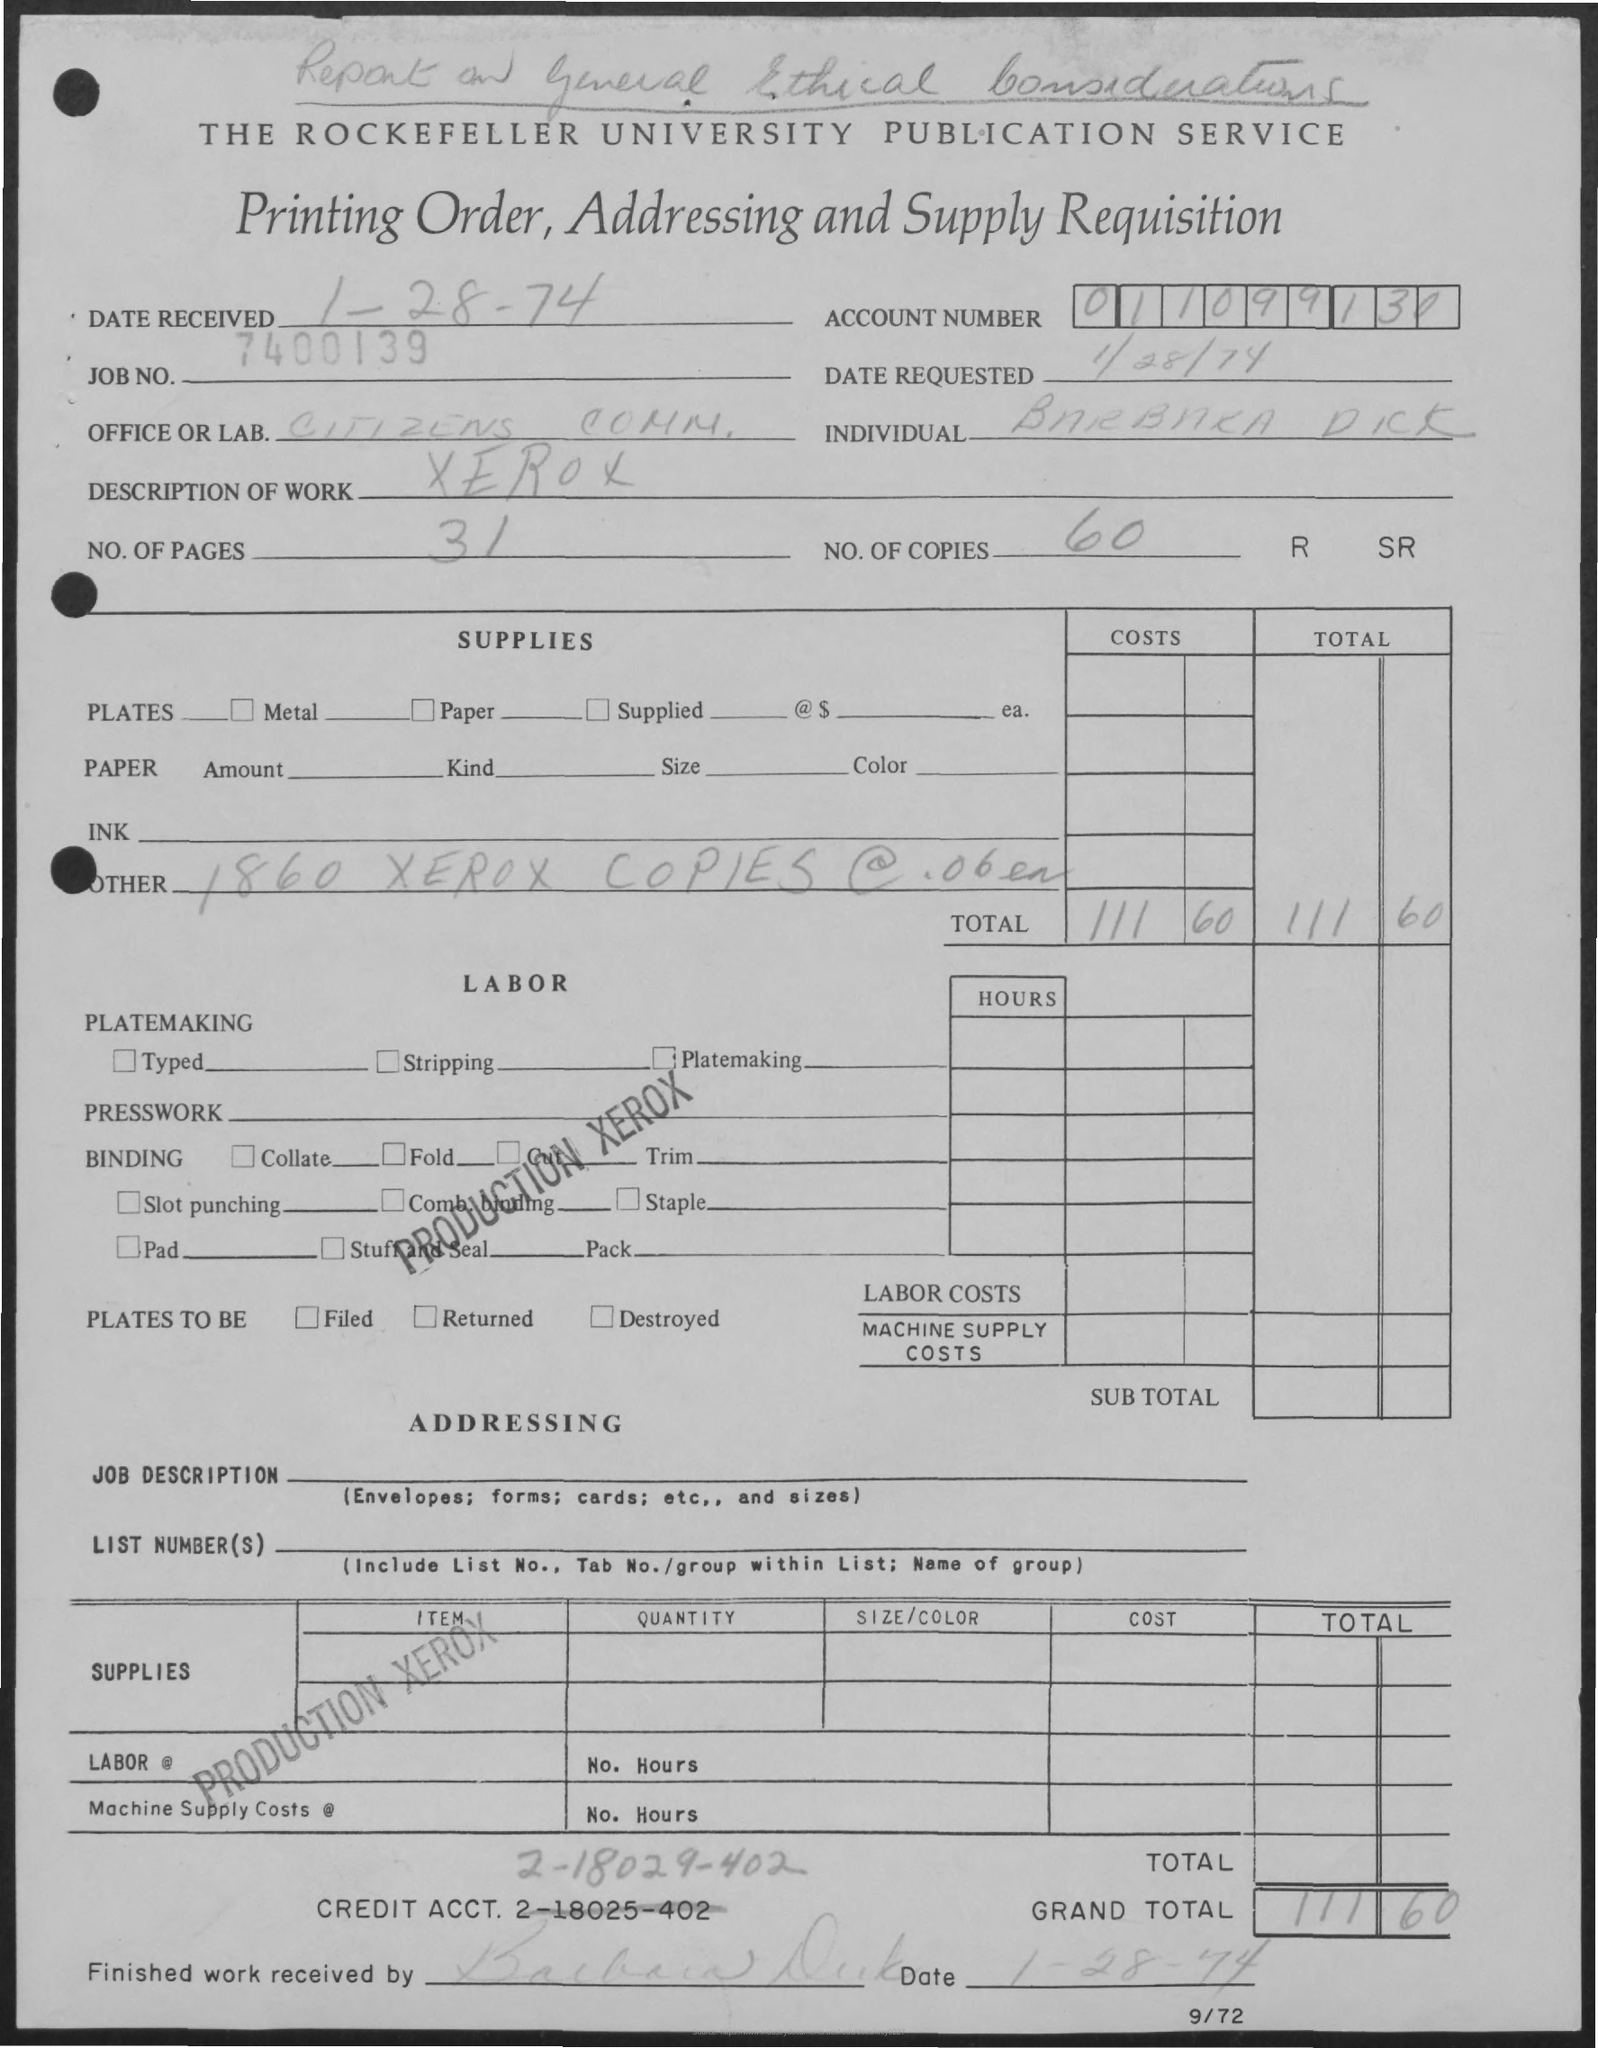What is the Job No.? The Job Number as indicated on the document is 7400139. 